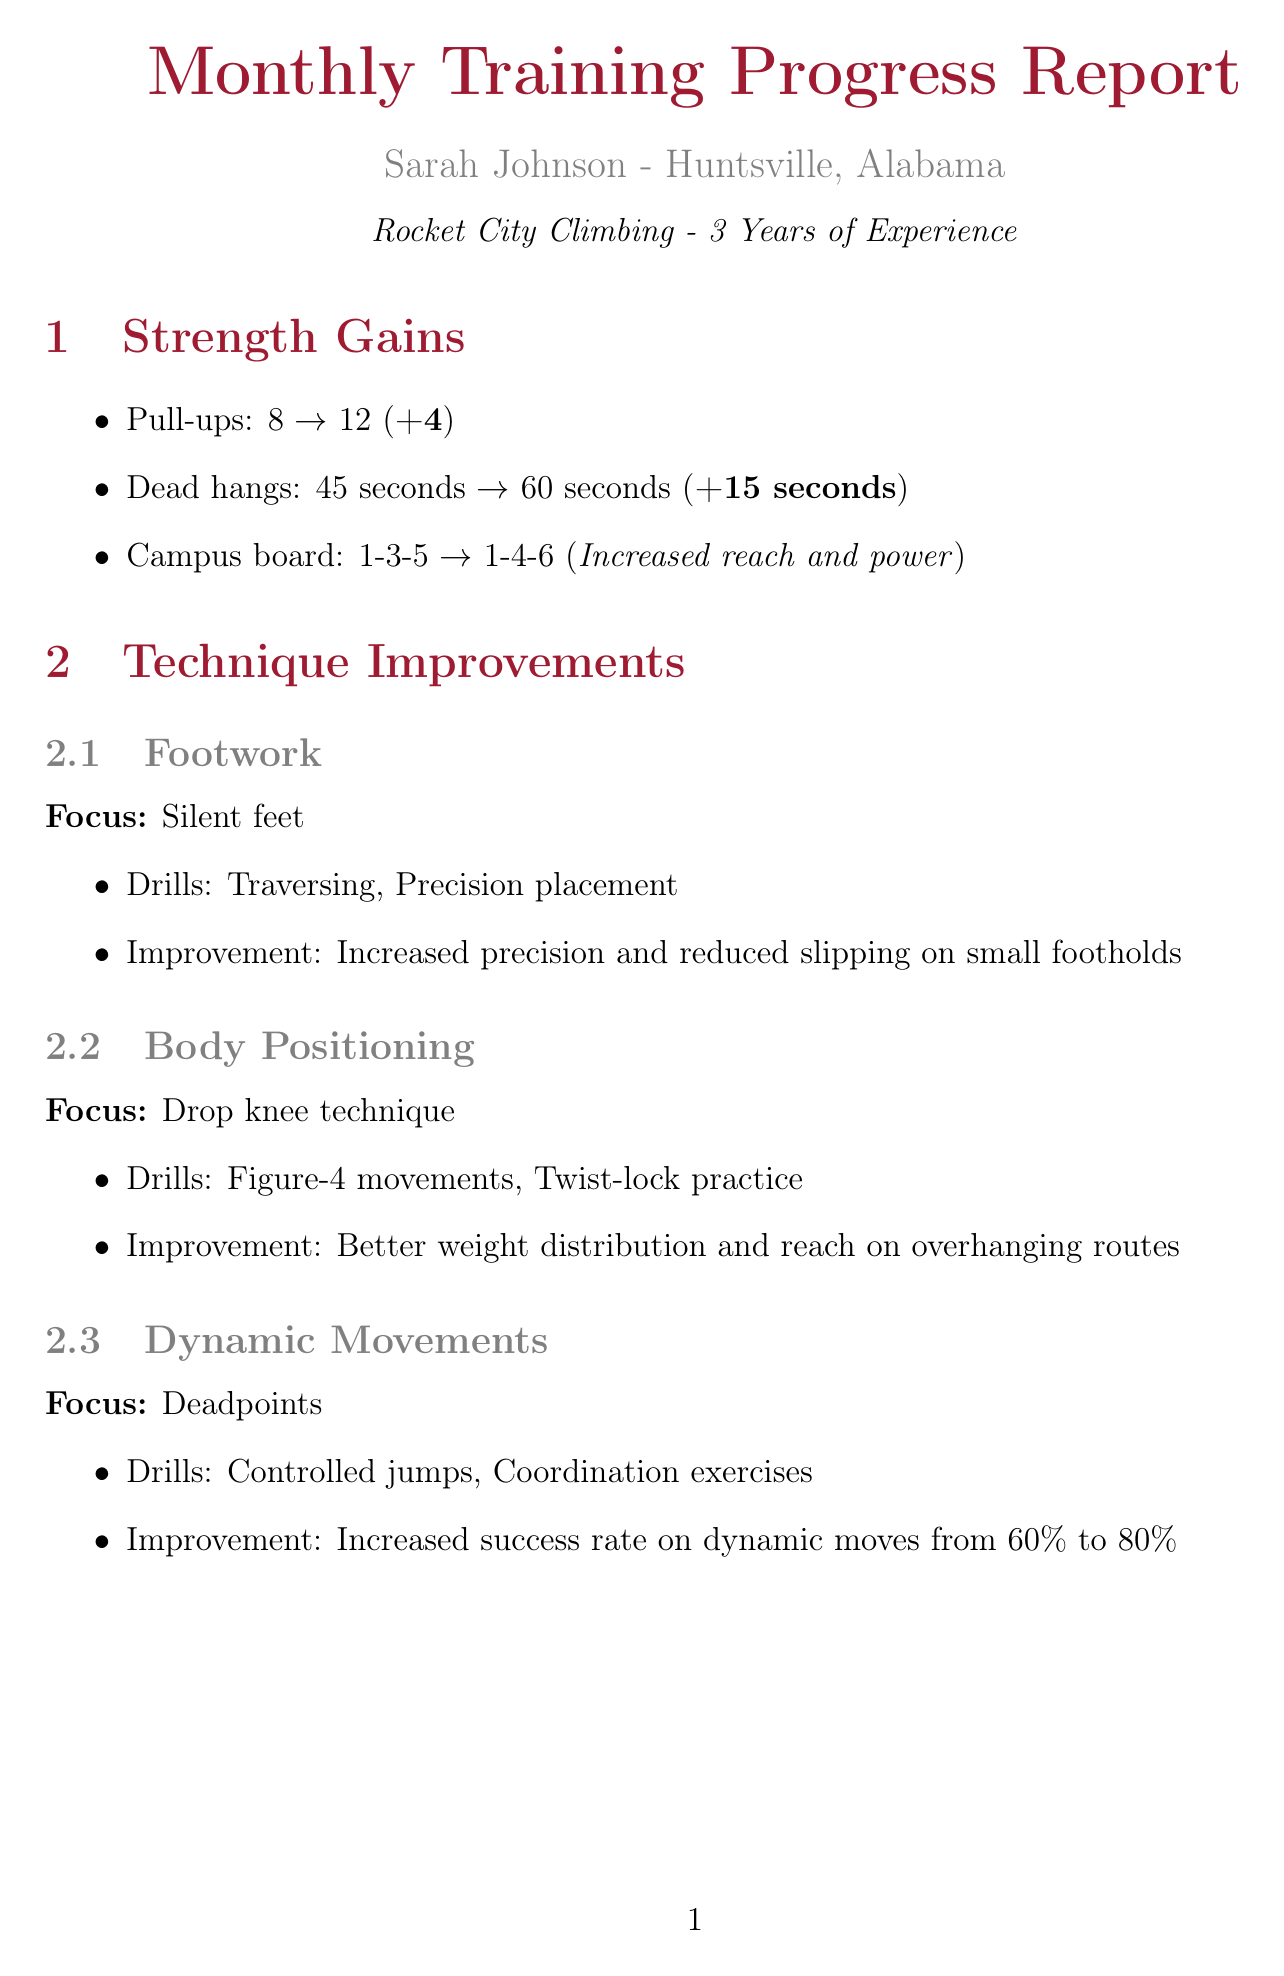What is Sarah's location? Sarah's location is specified in the document, which is Huntsville, Alabama.
Answer: Huntsville, Alabama How many pull-ups did Sarah start with? The document provides the number of pull-ups at the start of the month, which is 8.
Answer: 8 What was Sarah's improvement in dead hangs? The document states the improvement in dead hangs from 45 seconds to 60 seconds, which is a gain of 15 seconds.
Answer: +15 seconds What technique area did Sarah focus on for footwork? The focus area for footwork mentioned in the document is "Silent feet."
Answer: Silent feet What notable sends did Sarah achieve in indoor bouldering? The document lists two notable sends in indoor bouldering: "The Crimper's Delight" and "Roof Rider."
Answer: The Crimper's Delight, Roof Rider What is Sarah's goal for next month related to bouldering? The goals for next month include projecting a V6 boulder problem, which is noted in the document.
Answer: Project a V6 boulder problem In which competition is Sarah participating next month? The document states the name of the competition Sarah is participating in, which is the Alabama Climbing Series - Huntsville Edition.
Answer: Alabama Climbing Series - Huntsville Edition What percentage success rate did Sarah achieve on dynamic moves? The document indicates that Sarah increased her success rate on dynamic moves from 60% to 80%.
Answer: 80% 